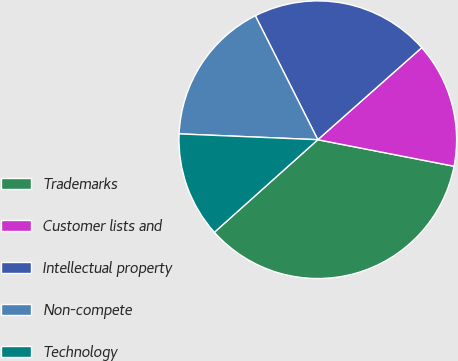Convert chart. <chart><loc_0><loc_0><loc_500><loc_500><pie_chart><fcel>Trademarks<fcel>Customer lists and<fcel>Intellectual property<fcel>Non-compete<fcel>Technology<nl><fcel>35.32%<fcel>14.6%<fcel>20.89%<fcel>16.9%<fcel>12.29%<nl></chart> 